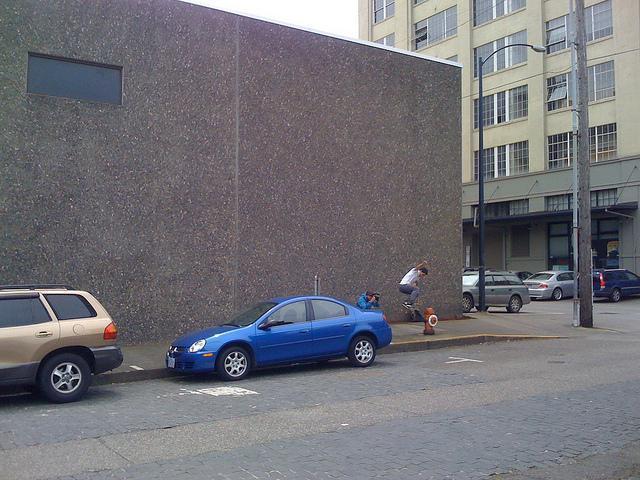How many cars can be seen?
Give a very brief answer. 5. How many cars are there?
Give a very brief answer. 3. 